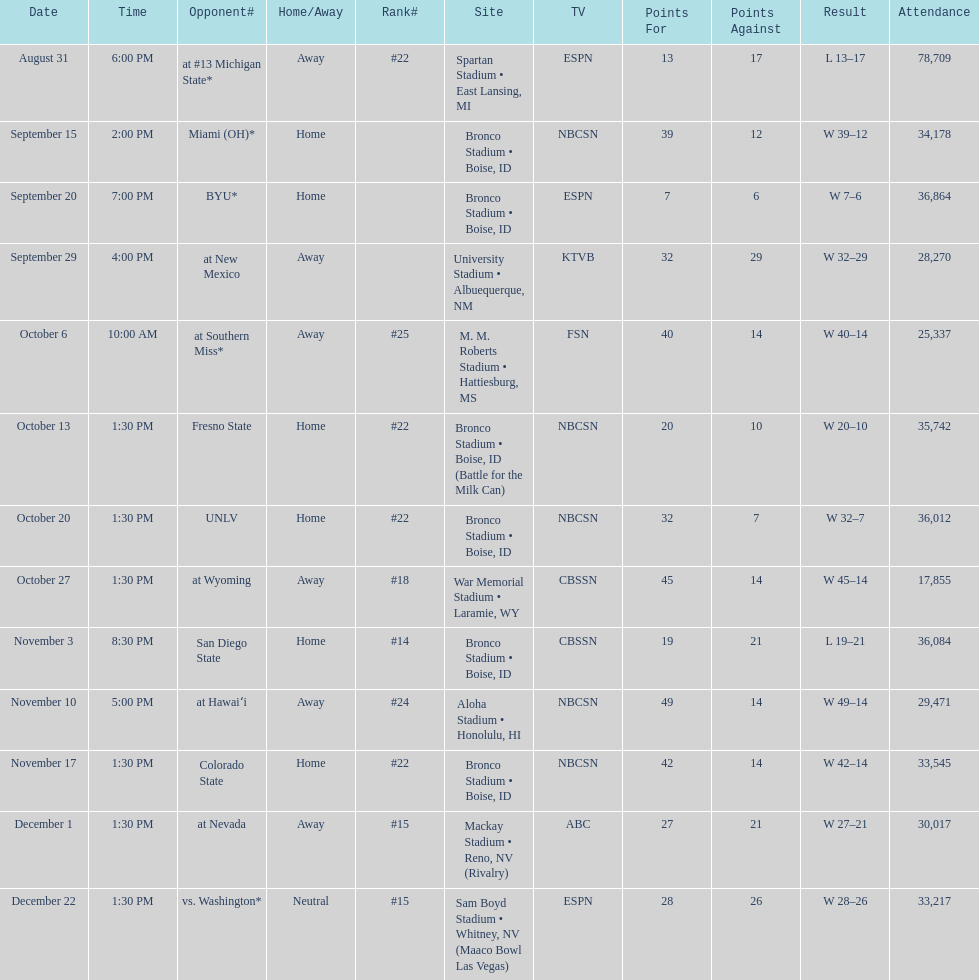What rank was boise state after november 10th? #22. 